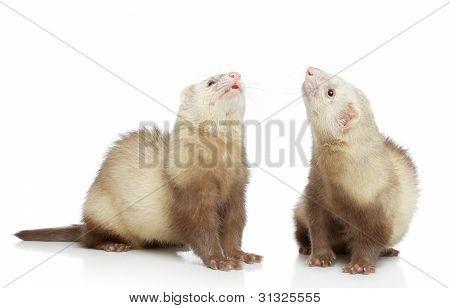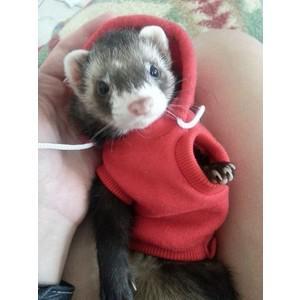The first image is the image on the left, the second image is the image on the right. Assess this claim about the two images: "Two ferrets are standing.". Correct or not? Answer yes or no. Yes. The first image is the image on the left, the second image is the image on the right. Examine the images to the left and right. Is the description "The left image shows side-by-side ferrets standing on their own feet, and the right image shows a single forward-facing ferret." accurate? Answer yes or no. Yes. 